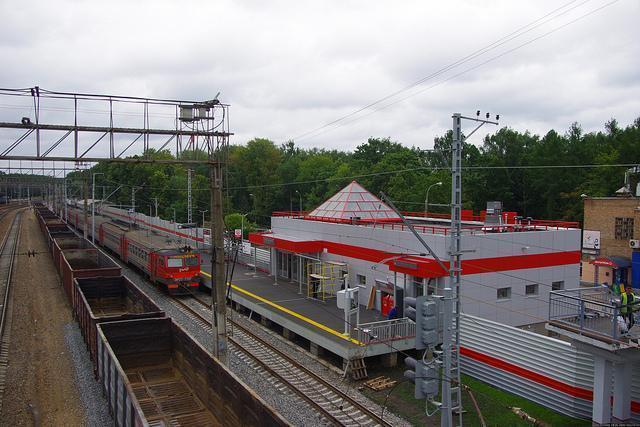These walls have a similar color scheme to what place?
Answer the question by selecting the correct answer among the 4 following choices and explain your choice with a short sentence. The answer should be formatted with the following format: `Answer: choice
Rationale: rationale.`
Options: Nathan's, arthur treacher's, popeye's, kfc. Answer: kfc.
Rationale: The colors are like kfc because you red and grey on the building 